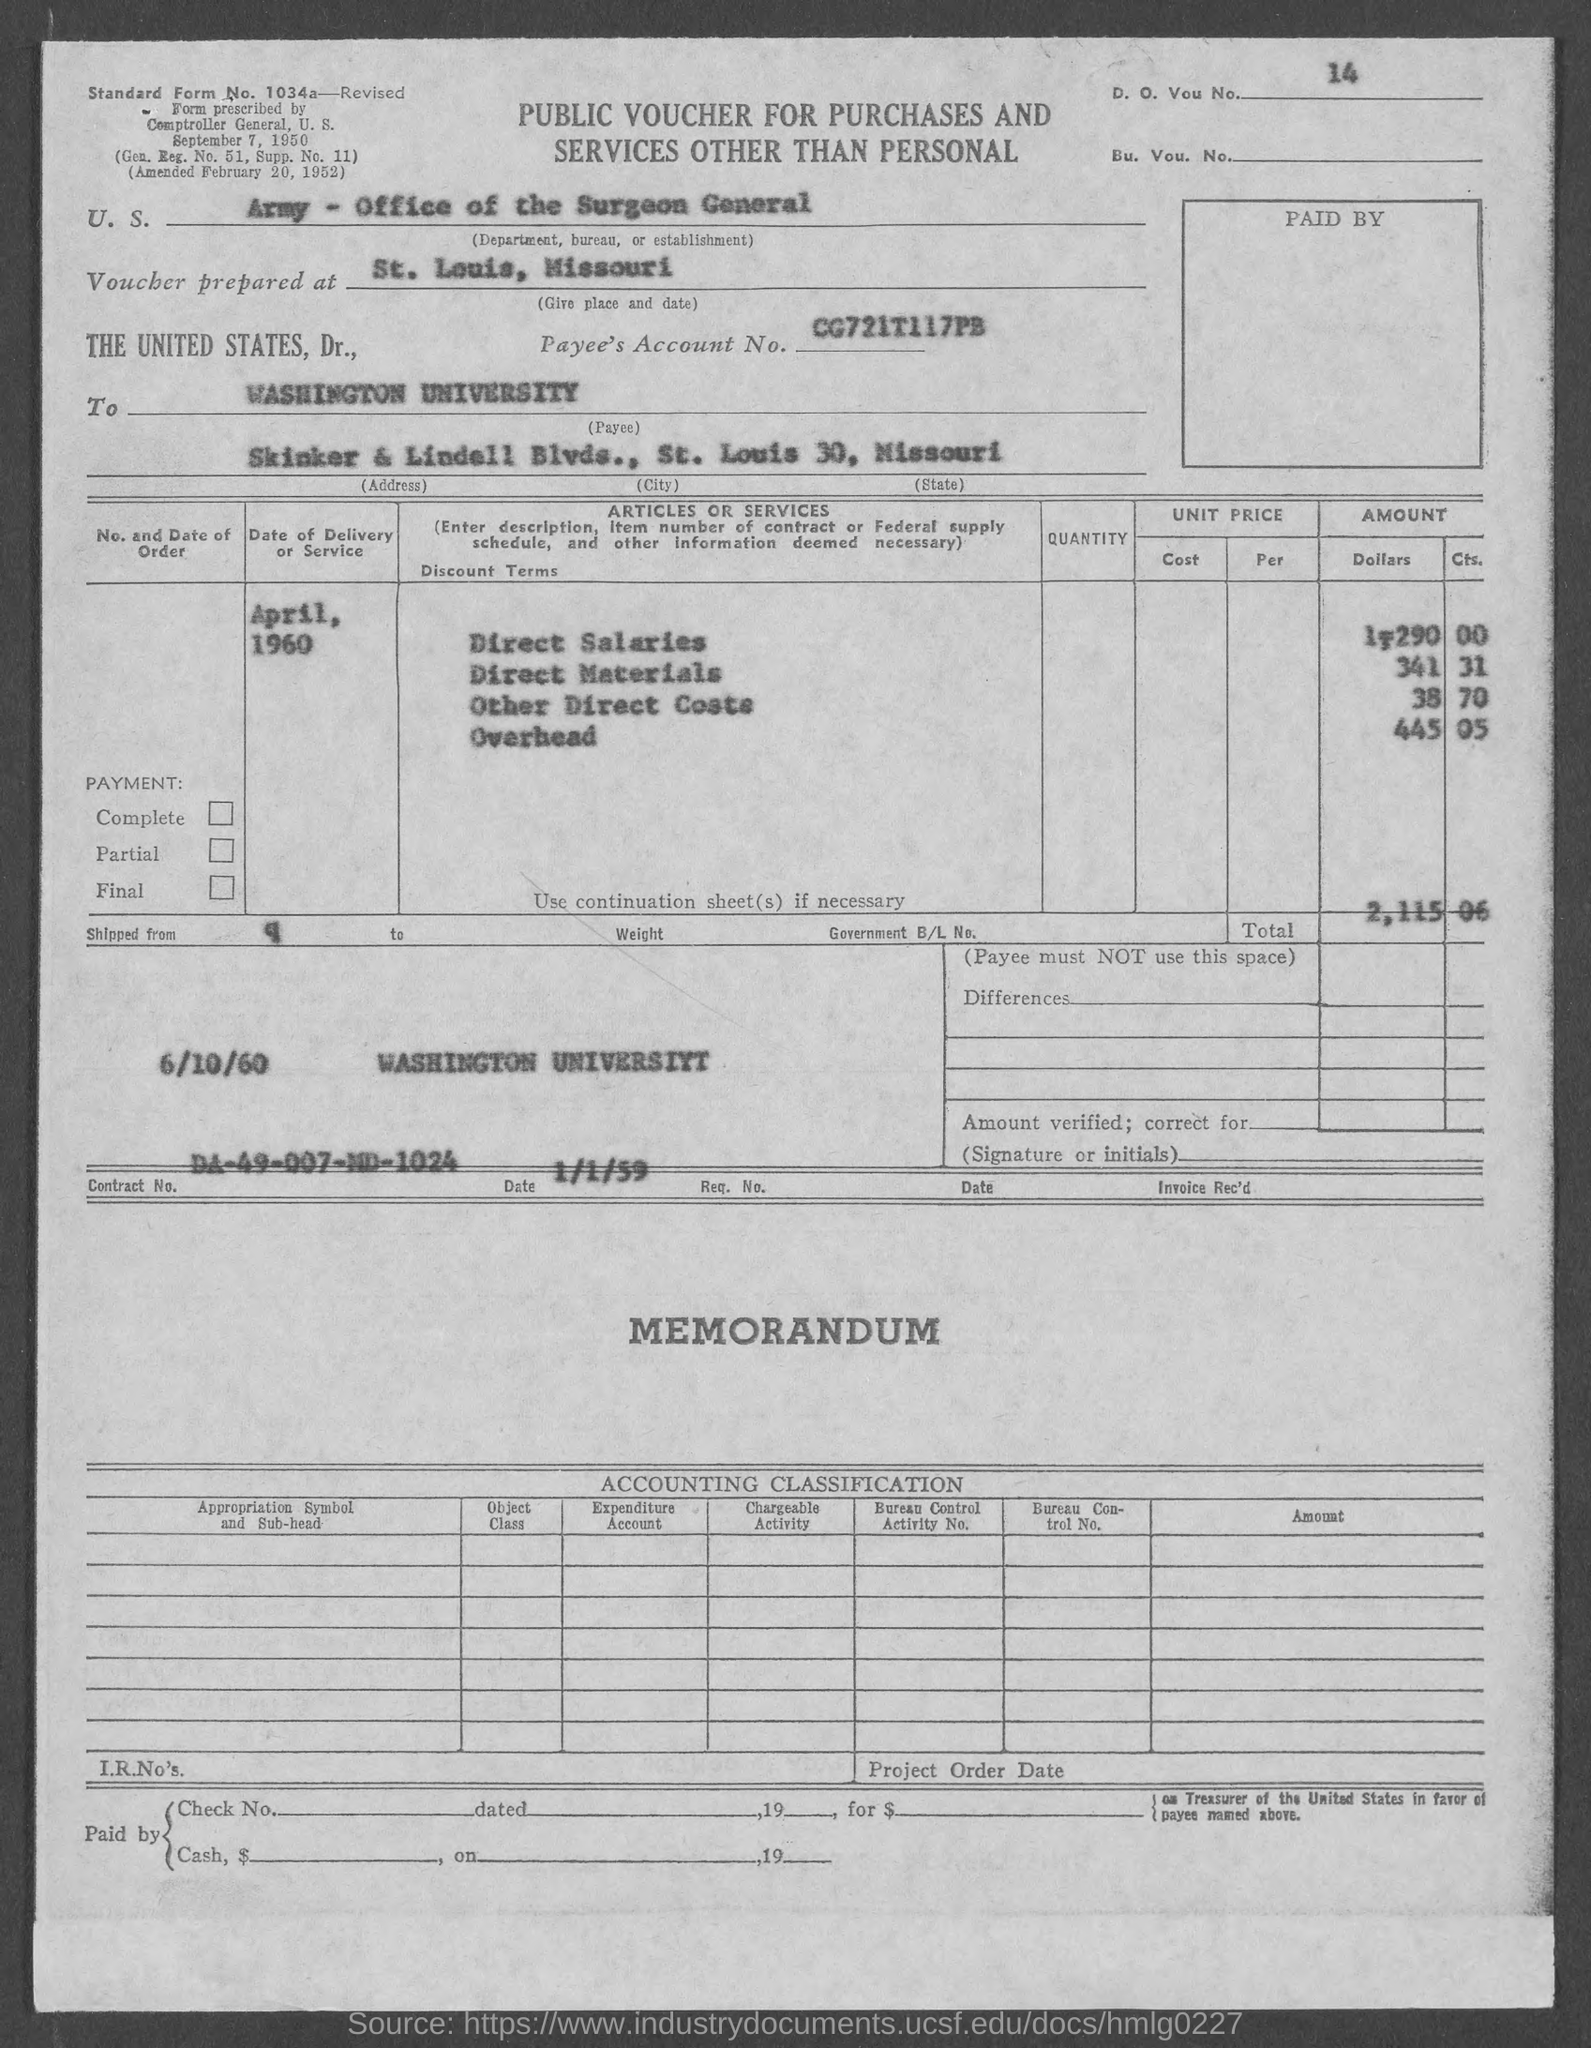Highlight a few significant elements in this photo. The payee name listed in the voucher is "Washington University. The Contract No. given in the voucher is DA-49-007-MD-1024. The voucher number given in the document is 14.. The date of delivery of service mentioned in the voucher is April 1960. The voucher was prepared at St. Louis, Missouri. 